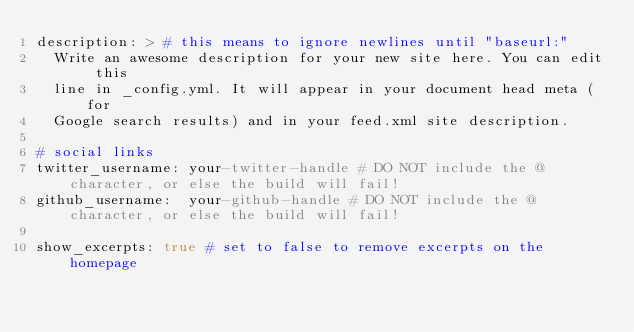<code> <loc_0><loc_0><loc_500><loc_500><_YAML_>description: > # this means to ignore newlines until "baseurl:"
  Write an awesome description for your new site here. You can edit this
  line in _config.yml. It will appear in your document head meta (for
  Google search results) and in your feed.xml site description.

# social links
twitter_username: your-twitter-handle # DO NOT include the @ character, or else the build will fail!
github_username:  your-github-handle # DO NOT include the @ character, or else the build will fail!

show_excerpts: true # set to false to remove excerpts on the homepage
</code> 